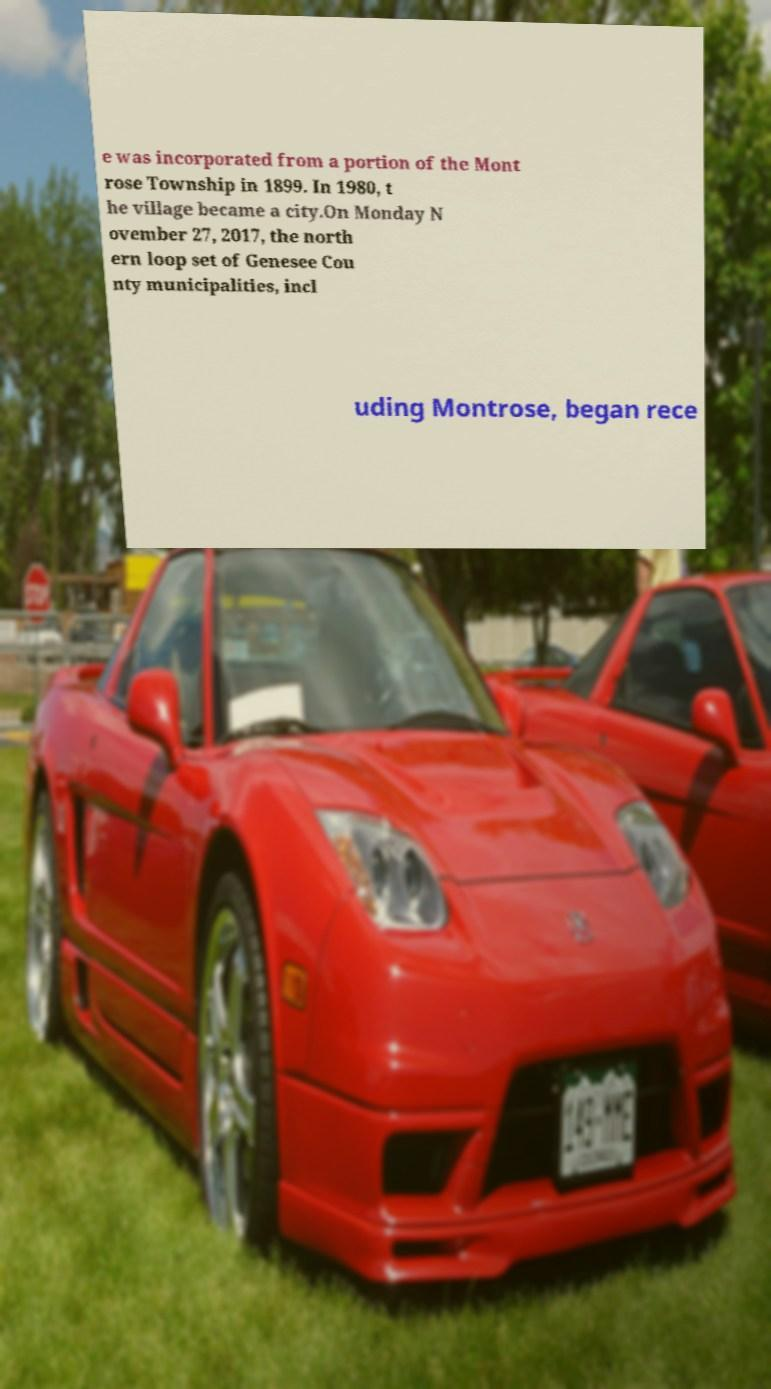Can you accurately transcribe the text from the provided image for me? e was incorporated from a portion of the Mont rose Township in 1899. In 1980, t he village became a city.On Monday N ovember 27, 2017, the north ern loop set of Genesee Cou nty municipalities, incl uding Montrose, began rece 